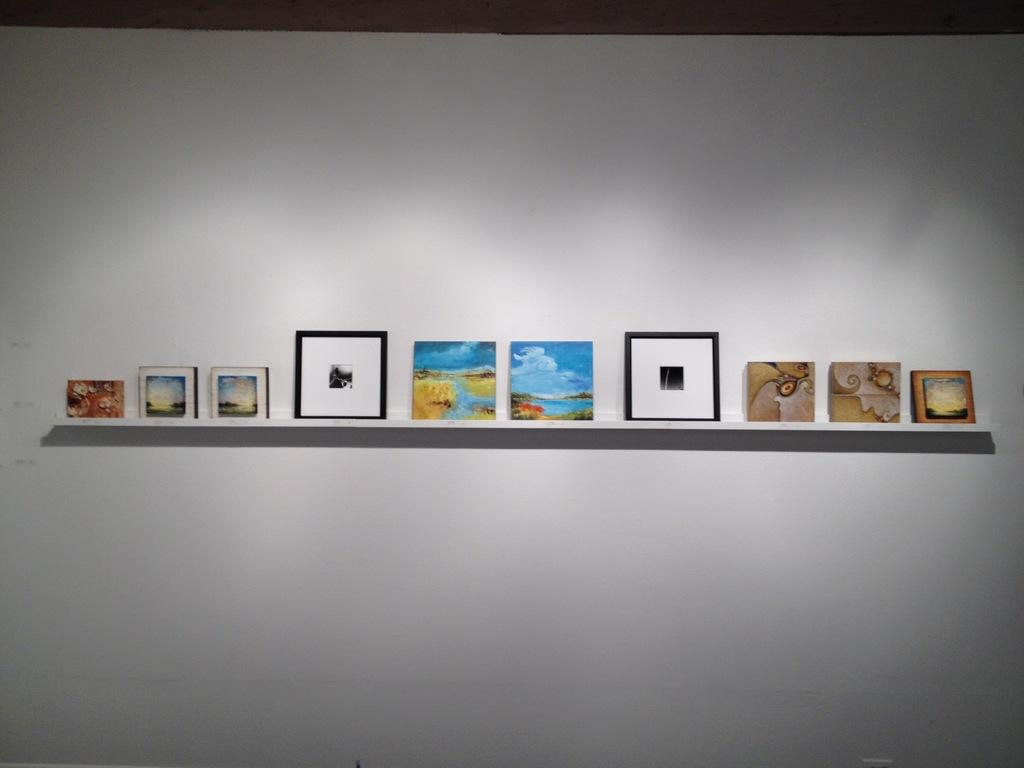What is present on the wall in the image? There is a stand on the wall in the image. What is the stand used for? The stand is used to hold photo frames. How many photo frames can be seen on the stand? The number of photo frames is not mentioned in the facts, so it cannot be determined from the image. What type of form or cause is depicted in the photo frames on the stand? There is no form or cause depicted in the photo frames on the stand; they likely contain photographs or images. Can you tell me how many family members are present in the photo frames on the stand? The number of family members cannot be determined from the image, as the contents of the photo frames are not visible. 